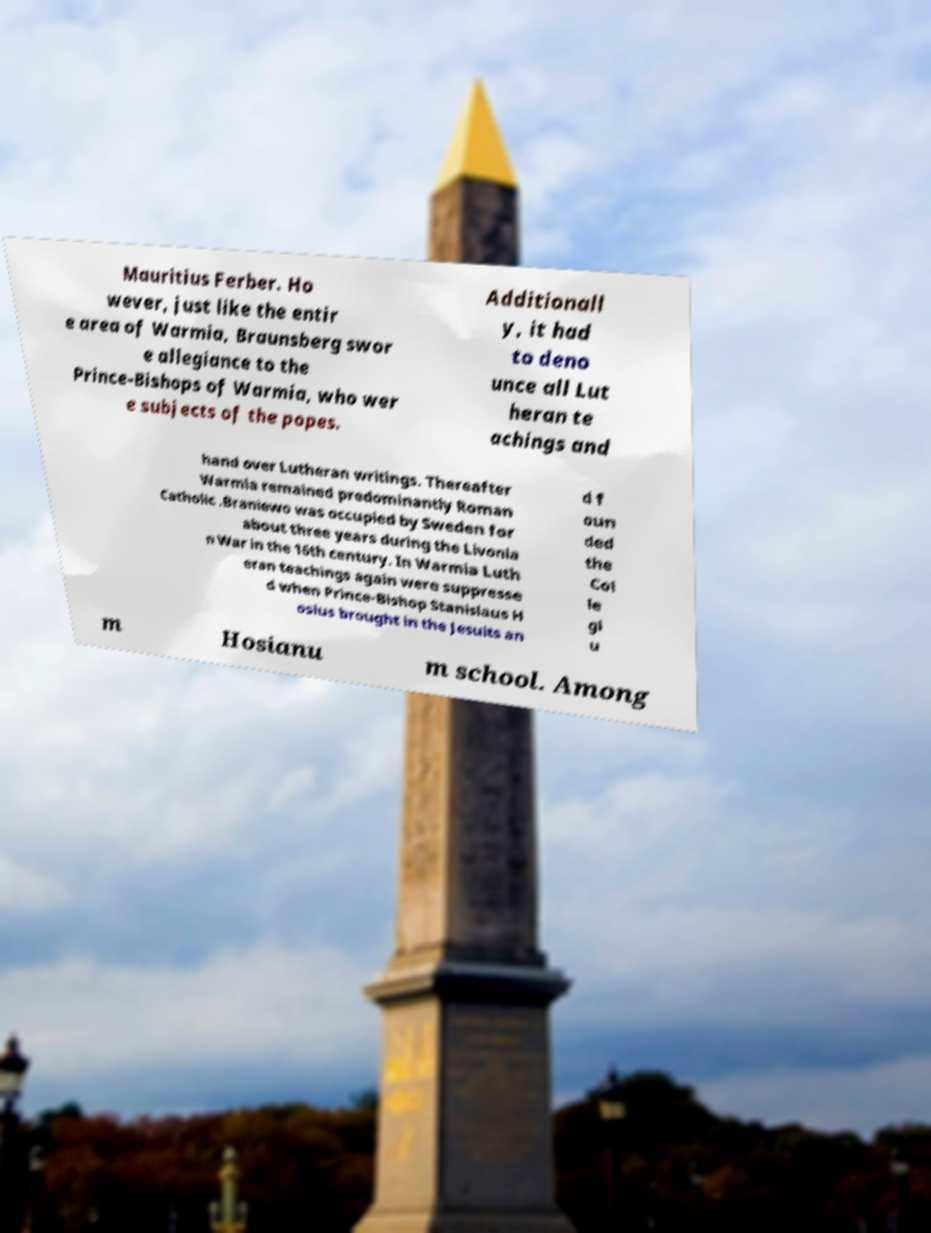For documentation purposes, I need the text within this image transcribed. Could you provide that? Mauritius Ferber. Ho wever, just like the entir e area of Warmia, Braunsberg swor e allegiance to the Prince-Bishops of Warmia, who wer e subjects of the popes. Additionall y, it had to deno unce all Lut heran te achings and hand over Lutheran writings. Thereafter Warmia remained predominantly Roman Catholic .Braniewo was occupied by Sweden for about three years during the Livonia n War in the 16th century. In Warmia Luth eran teachings again were suppresse d when Prince-Bishop Stanislaus H osius brought in the Jesuits an d f oun ded the Col le gi u m Hosianu m school. Among 